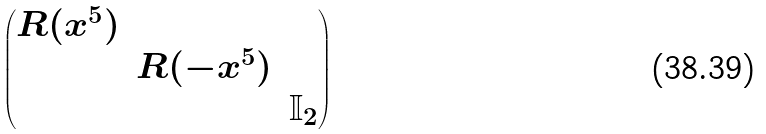<formula> <loc_0><loc_0><loc_500><loc_500>\begin{pmatrix} R ( x ^ { 5 } ) & & \\ & R ( - x ^ { 5 } ) & \\ & & \mathbb { I } _ { 2 } \end{pmatrix}</formula> 